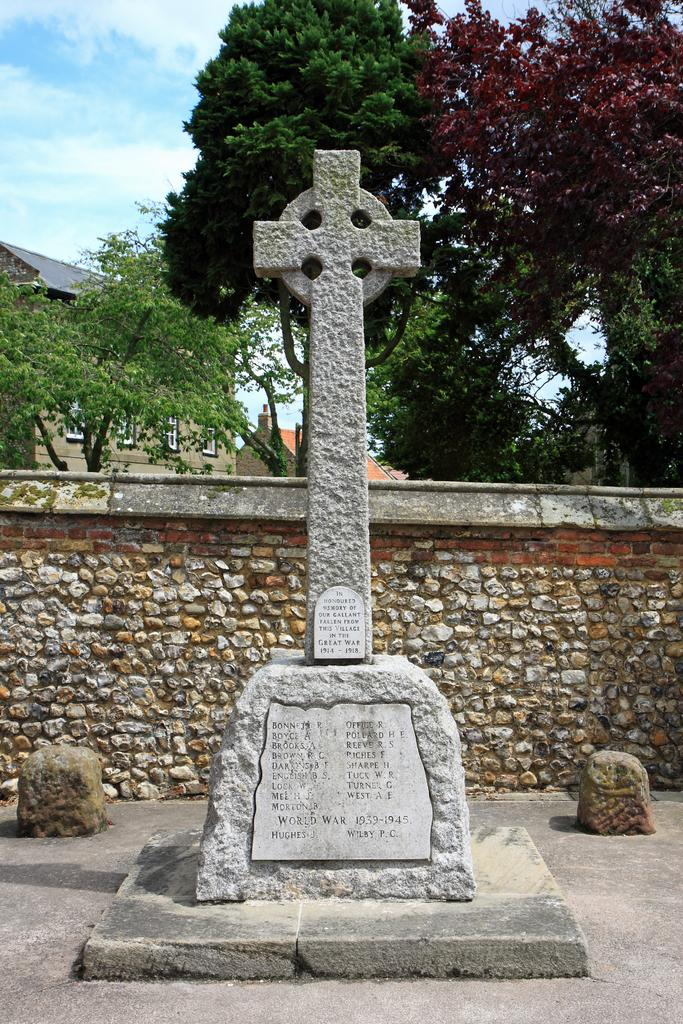What type of structure is depicted in the image? The image appears to be a memorial stone. What is the surrounding area like in the image? There is a compound wall in the image, and trees with branches and leaves are present. What can be seen in the background of the image? Buildings with windows are visible in the background. What type of bed is visible in the image? There is no bed present in the image; it features a memorial stone and its surroundings. 